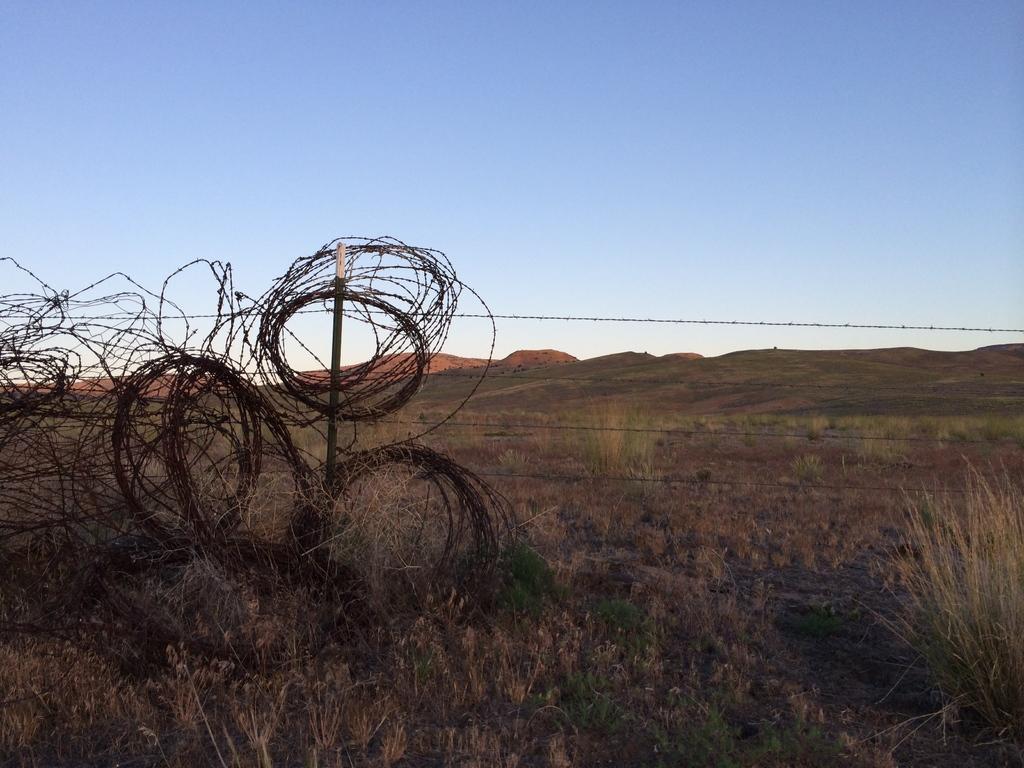Could you give a brief overview of what you see in this image? This is an outside view. At the bottom, I can see the grass on the ground. On the left side there is barbed wire and also there is a fencing. At the top of the image I can see the sky in blue color. 